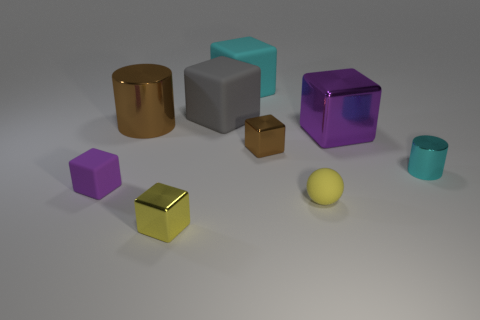What material is the big object that is the same color as the tiny cylinder?
Your answer should be very brief. Rubber. What number of objects are big blue balls or small metal blocks?
Make the answer very short. 2. Does the purple object to the right of the large brown metallic cylinder have the same material as the small cyan cylinder?
Provide a succinct answer. Yes. What number of objects are tiny cubes on the left side of the brown metallic block or cyan rubber blocks?
Provide a short and direct response. 3. There is another large cube that is the same material as the big cyan cube; what color is it?
Provide a succinct answer. Gray. Is there a matte cube that has the same size as the purple shiny cube?
Keep it short and to the point. Yes. Does the large cube to the left of the big cyan thing have the same color as the tiny matte block?
Keep it short and to the point. No. The tiny shiny thing that is both in front of the brown metallic block and on the right side of the yellow cube is what color?
Provide a succinct answer. Cyan. What shape is the cyan metallic thing that is the same size as the yellow matte sphere?
Offer a very short reply. Cylinder. Is there a tiny purple object of the same shape as the yellow metallic thing?
Your answer should be very brief. Yes. 